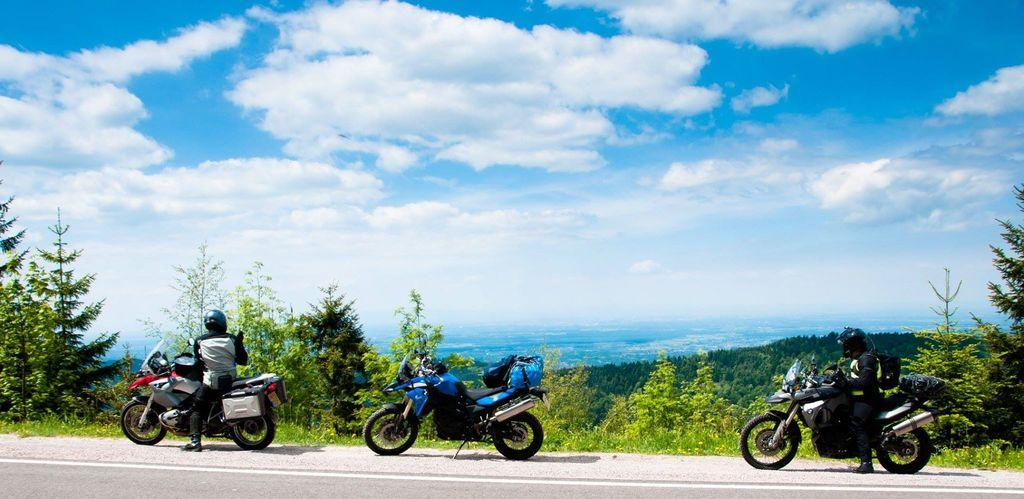What can be seen in the image? There are bikes in the image. What type of vegetation is present at the bottom side of the image? There are trees at the bottom side of the image. What is visible at the top side of the image? The sky is visible at the top side of the image. Can you describe the observation beetle made in the middle of the image? There is no beetle or observation present in the image; it features bikes, trees, and the sky. 